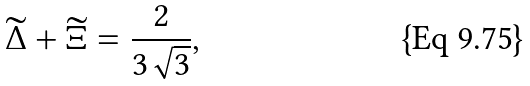<formula> <loc_0><loc_0><loc_500><loc_500>\widetilde { \Delta } + \widetilde { \Xi } = \frac { 2 } { 3 \sqrt { 3 } } ,</formula> 